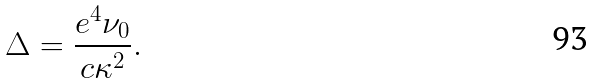Convert formula to latex. <formula><loc_0><loc_0><loc_500><loc_500>\Delta = \frac { e ^ { 4 } \nu _ { 0 } } { c \kappa ^ { 2 } } .</formula> 